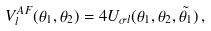<formula> <loc_0><loc_0><loc_500><loc_500>V _ { l } ^ { A F } ( \theta _ { 1 } , \theta _ { 2 } ) = 4 U _ { \sigma l } ( \theta _ { 1 } , \theta _ { 2 } , \tilde { \theta _ { 1 } } ) \, ,</formula> 